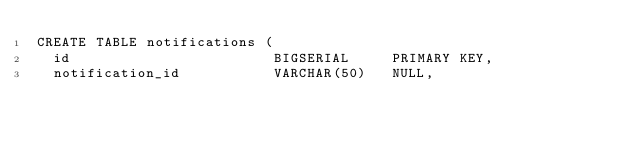<code> <loc_0><loc_0><loc_500><loc_500><_SQL_>CREATE TABLE notifications (
  id                        BIGSERIAL     PRIMARY KEY,
  notification_id           VARCHAR(50)   NULL,</code> 